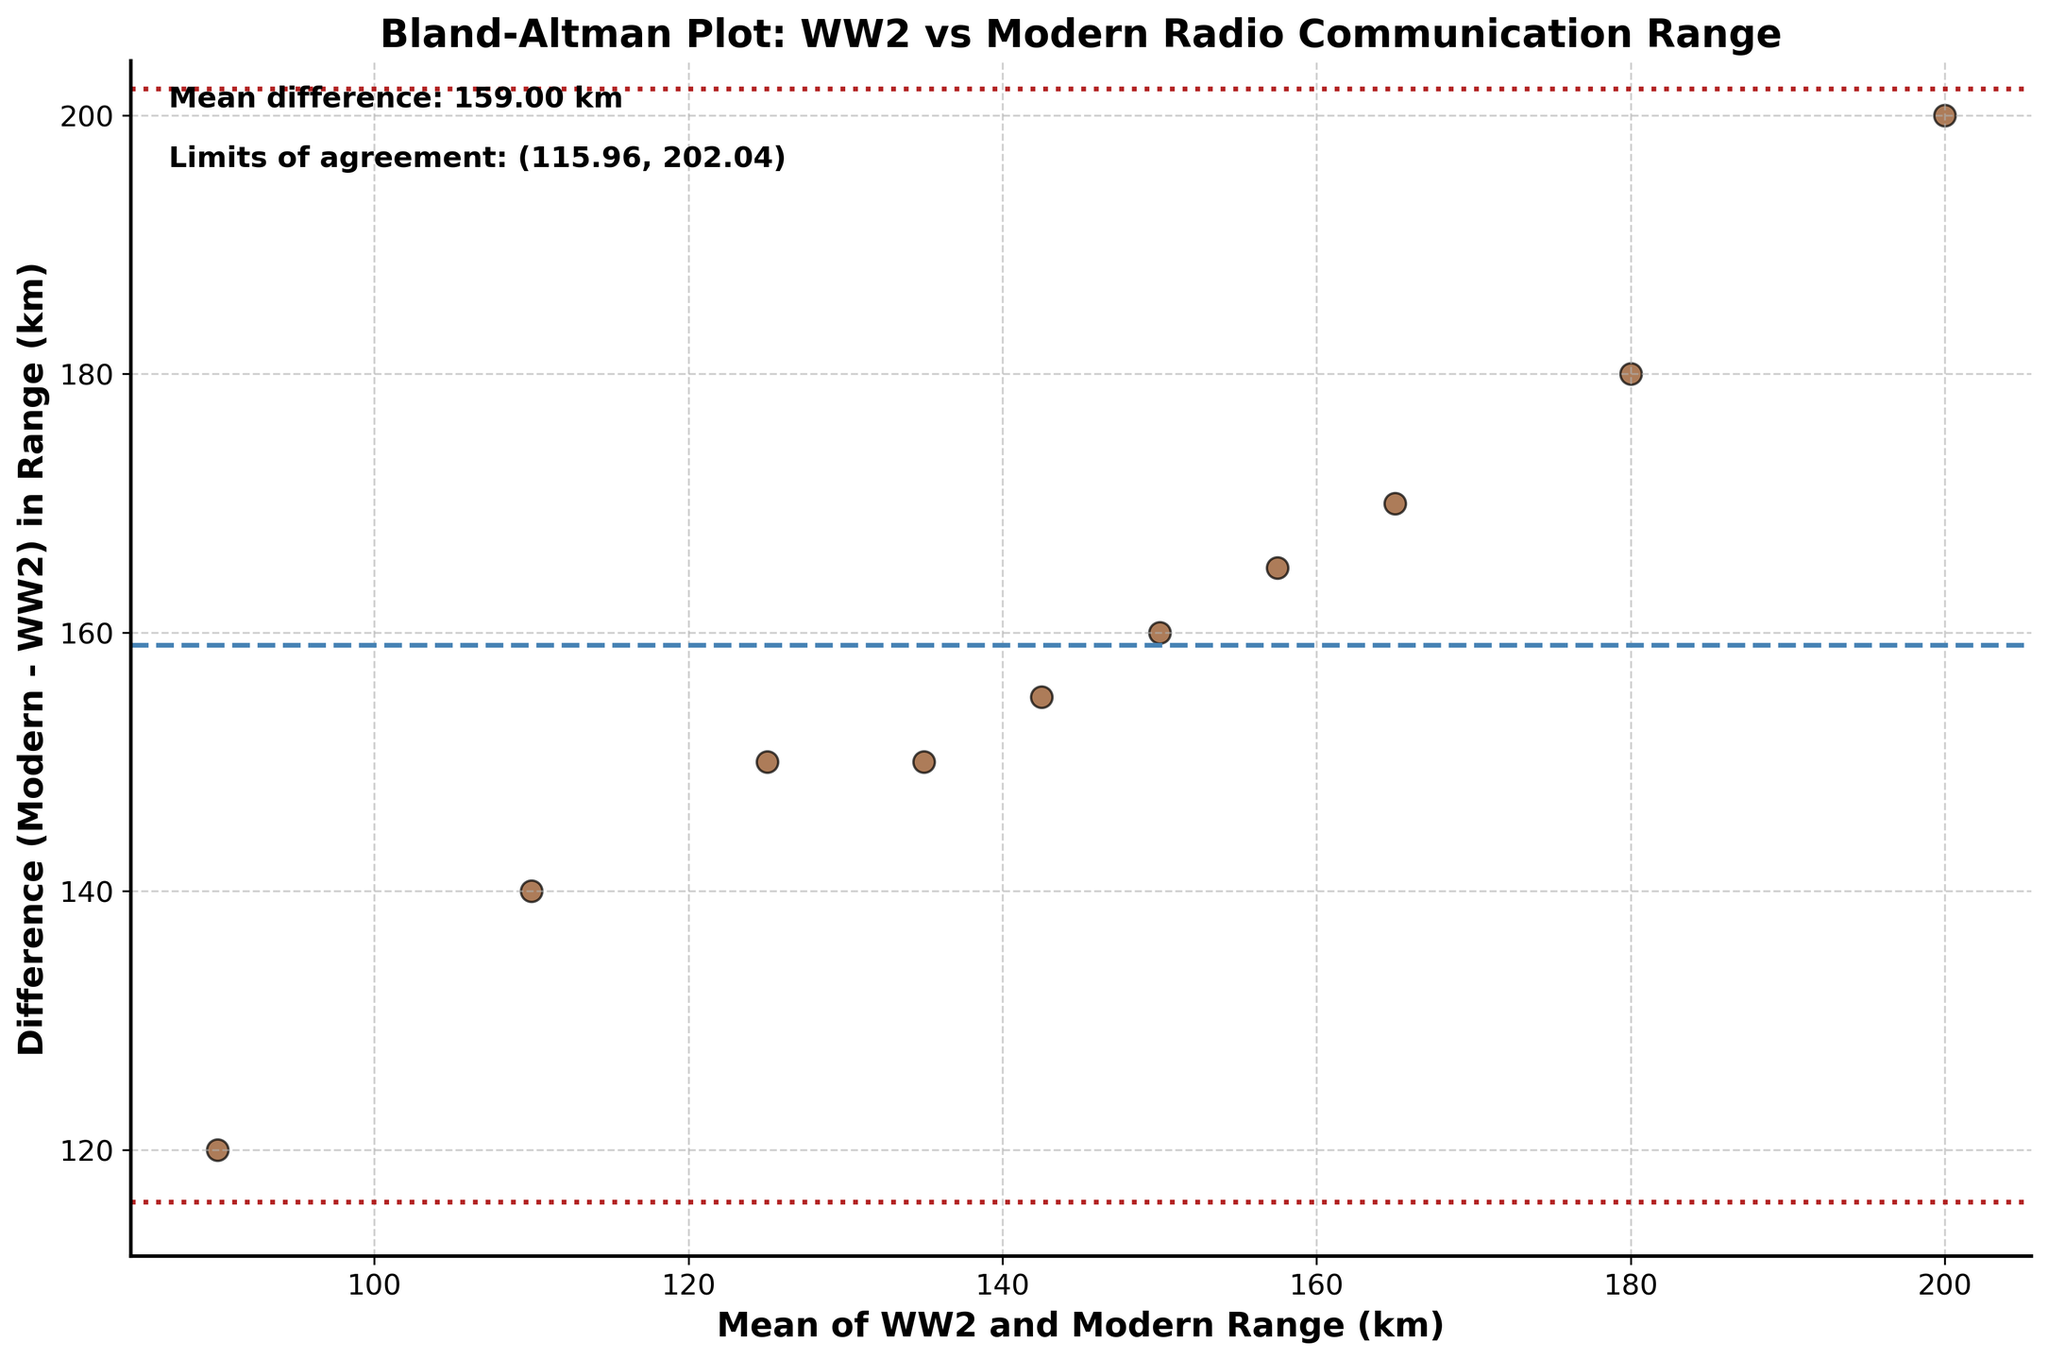What is the title of the Bland-Altman plot? The title of the plot is typically found at the top of the figure. In this case, the title is clearly labeled as "Bland-Altman Plot: WW2 vs Modern Radio Communication Range".
Answer: Bland-Altman Plot: WW2 vs Modern Radio Communication Range How many data points are plotted in the Bland-Altman plot? Each data point usually represents a pair of measurements; the figure would visually show the number of such pairs plotted. Here, there are 10 data points plotted, corresponding to the 10 atmospheric conditions listed in the data.
Answer: 10 What do the two dotted red lines represent in the figure? The two dotted red lines in a Bland-Altman plot typically represent the limits of agreement. The lower and upper limits are calculated as the mean difference ± 1.96 times the standard deviation of the differences.
Answer: Limits of agreement What is the mean difference in range between WW2 and modern communication systems? The mean difference line is often shown as a dashed line, and it is also indicated in the plot's annotation. Here, the mean difference is noted as 156.00 km.
Answer: 156.00 km Which condition has the largest difference in range between WW2 and modern systems, based on the Bland-Altman plot? To find the largest difference, look for the point farthest from the mean difference line. This difference can be derived from the condition at high altitude, where the difference is 200 km (300 km [modern] - 100 km [WW2]).
Answer: High Altitude How do you interpret a point that falls outside the limits of agreement? Points outside the limits of agreement indicate that the measurement differences are unusually large and may suggest error, variability, or a non-systematic bias under those conditions. Though no points fall outside the limits in this plot.
Answer: Unusually large difference What does the point farthest below the mean difference line represent in terms of conditions? The point farthest below the mean difference line reflects the condition with the smallest difference in range. Here, it is Fog, with a difference of 120 km (150 km [modern] - 30 km [WW2]).
Answer: Fog What is the maximum difference in clarity between WW2 and modern systems? While clarity is not directly plotted, reviewing differences in clarity from the data shows the maximum difference to be under Heavy Rain, with a difference of 3 (7 [modern] - 4 [WW2]).
Answer: Heavy Rain Is the difference in radio communication range between WW2 and modern systems consistent across different conditions? Consistency can be assessed by how close the points are to the mean difference line and within the limits of agreement. Here, points are relatively close to mean difference line and within limits, indicating some consistency but with notable variability.
Answer: Relatively consistent but variable What can be inferred about night-time conditions based on this plot? The night-time condition's data point is close to the mean difference line, indicating the difference in range is close to the average case (150 km [modern] - 75 km [WW2] = 165 km), thus within expected variation.
Answer: Within expected variation 